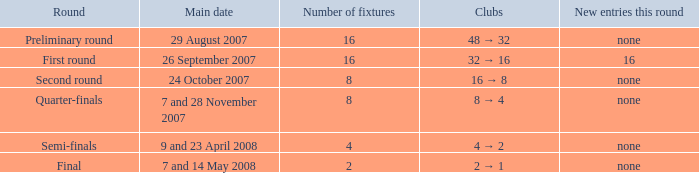What is the clubs when 4 fixtures are present? 4 → 2. 